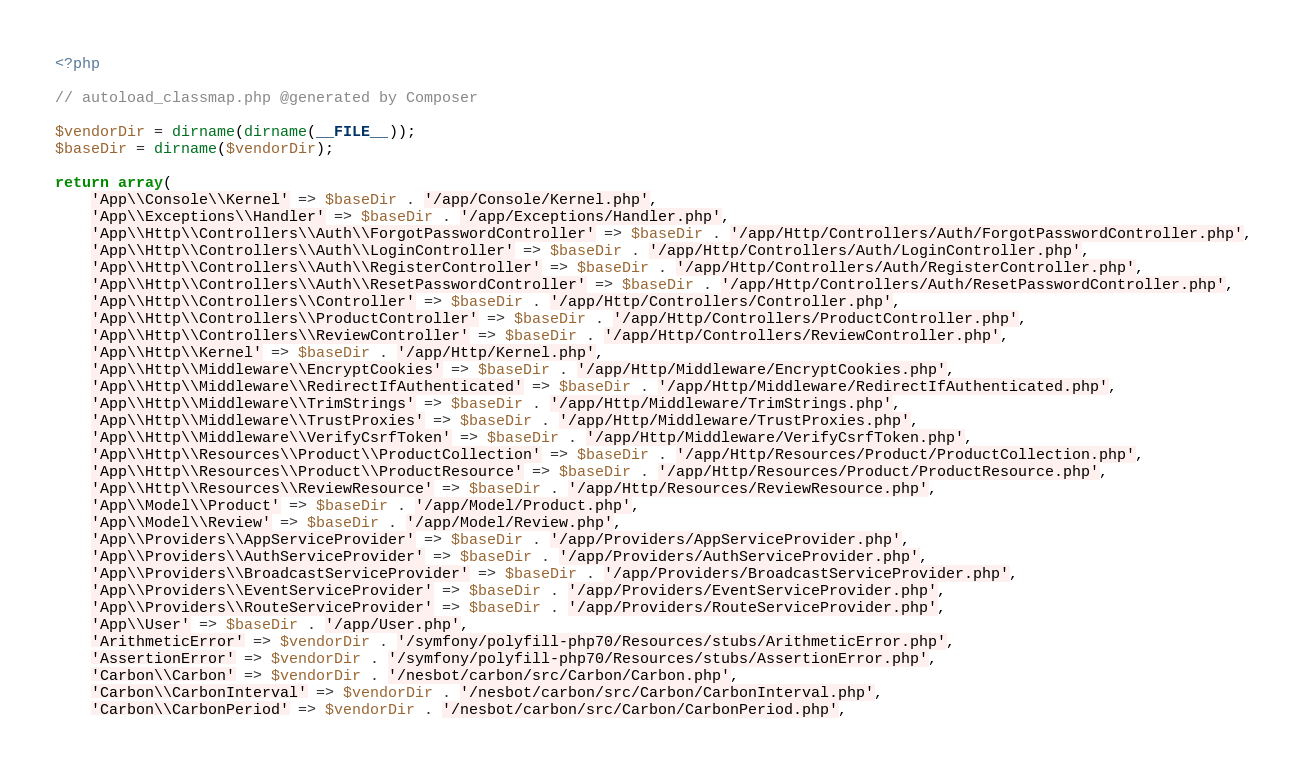Convert code to text. <code><loc_0><loc_0><loc_500><loc_500><_PHP_><?php

// autoload_classmap.php @generated by Composer

$vendorDir = dirname(dirname(__FILE__));
$baseDir = dirname($vendorDir);

return array(
    'App\\Console\\Kernel' => $baseDir . '/app/Console/Kernel.php',
    'App\\Exceptions\\Handler' => $baseDir . '/app/Exceptions/Handler.php',
    'App\\Http\\Controllers\\Auth\\ForgotPasswordController' => $baseDir . '/app/Http/Controllers/Auth/ForgotPasswordController.php',
    'App\\Http\\Controllers\\Auth\\LoginController' => $baseDir . '/app/Http/Controllers/Auth/LoginController.php',
    'App\\Http\\Controllers\\Auth\\RegisterController' => $baseDir . '/app/Http/Controllers/Auth/RegisterController.php',
    'App\\Http\\Controllers\\Auth\\ResetPasswordController' => $baseDir . '/app/Http/Controllers/Auth/ResetPasswordController.php',
    'App\\Http\\Controllers\\Controller' => $baseDir . '/app/Http/Controllers/Controller.php',
    'App\\Http\\Controllers\\ProductController' => $baseDir . '/app/Http/Controllers/ProductController.php',
    'App\\Http\\Controllers\\ReviewController' => $baseDir . '/app/Http/Controllers/ReviewController.php',
    'App\\Http\\Kernel' => $baseDir . '/app/Http/Kernel.php',
    'App\\Http\\Middleware\\EncryptCookies' => $baseDir . '/app/Http/Middleware/EncryptCookies.php',
    'App\\Http\\Middleware\\RedirectIfAuthenticated' => $baseDir . '/app/Http/Middleware/RedirectIfAuthenticated.php',
    'App\\Http\\Middleware\\TrimStrings' => $baseDir . '/app/Http/Middleware/TrimStrings.php',
    'App\\Http\\Middleware\\TrustProxies' => $baseDir . '/app/Http/Middleware/TrustProxies.php',
    'App\\Http\\Middleware\\VerifyCsrfToken' => $baseDir . '/app/Http/Middleware/VerifyCsrfToken.php',
    'App\\Http\\Resources\\Product\\ProductCollection' => $baseDir . '/app/Http/Resources/Product/ProductCollection.php',
    'App\\Http\\Resources\\Product\\ProductResource' => $baseDir . '/app/Http/Resources/Product/ProductResource.php',
    'App\\Http\\Resources\\ReviewResource' => $baseDir . '/app/Http/Resources/ReviewResource.php',
    'App\\Model\\Product' => $baseDir . '/app/Model/Product.php',
    'App\\Model\\Review' => $baseDir . '/app/Model/Review.php',
    'App\\Providers\\AppServiceProvider' => $baseDir . '/app/Providers/AppServiceProvider.php',
    'App\\Providers\\AuthServiceProvider' => $baseDir . '/app/Providers/AuthServiceProvider.php',
    'App\\Providers\\BroadcastServiceProvider' => $baseDir . '/app/Providers/BroadcastServiceProvider.php',
    'App\\Providers\\EventServiceProvider' => $baseDir . '/app/Providers/EventServiceProvider.php',
    'App\\Providers\\RouteServiceProvider' => $baseDir . '/app/Providers/RouteServiceProvider.php',
    'App\\User' => $baseDir . '/app/User.php',
    'ArithmeticError' => $vendorDir . '/symfony/polyfill-php70/Resources/stubs/ArithmeticError.php',
    'AssertionError' => $vendorDir . '/symfony/polyfill-php70/Resources/stubs/AssertionError.php',
    'Carbon\\Carbon' => $vendorDir . '/nesbot/carbon/src/Carbon/Carbon.php',
    'Carbon\\CarbonInterval' => $vendorDir . '/nesbot/carbon/src/Carbon/CarbonInterval.php',
    'Carbon\\CarbonPeriod' => $vendorDir . '/nesbot/carbon/src/Carbon/CarbonPeriod.php',</code> 